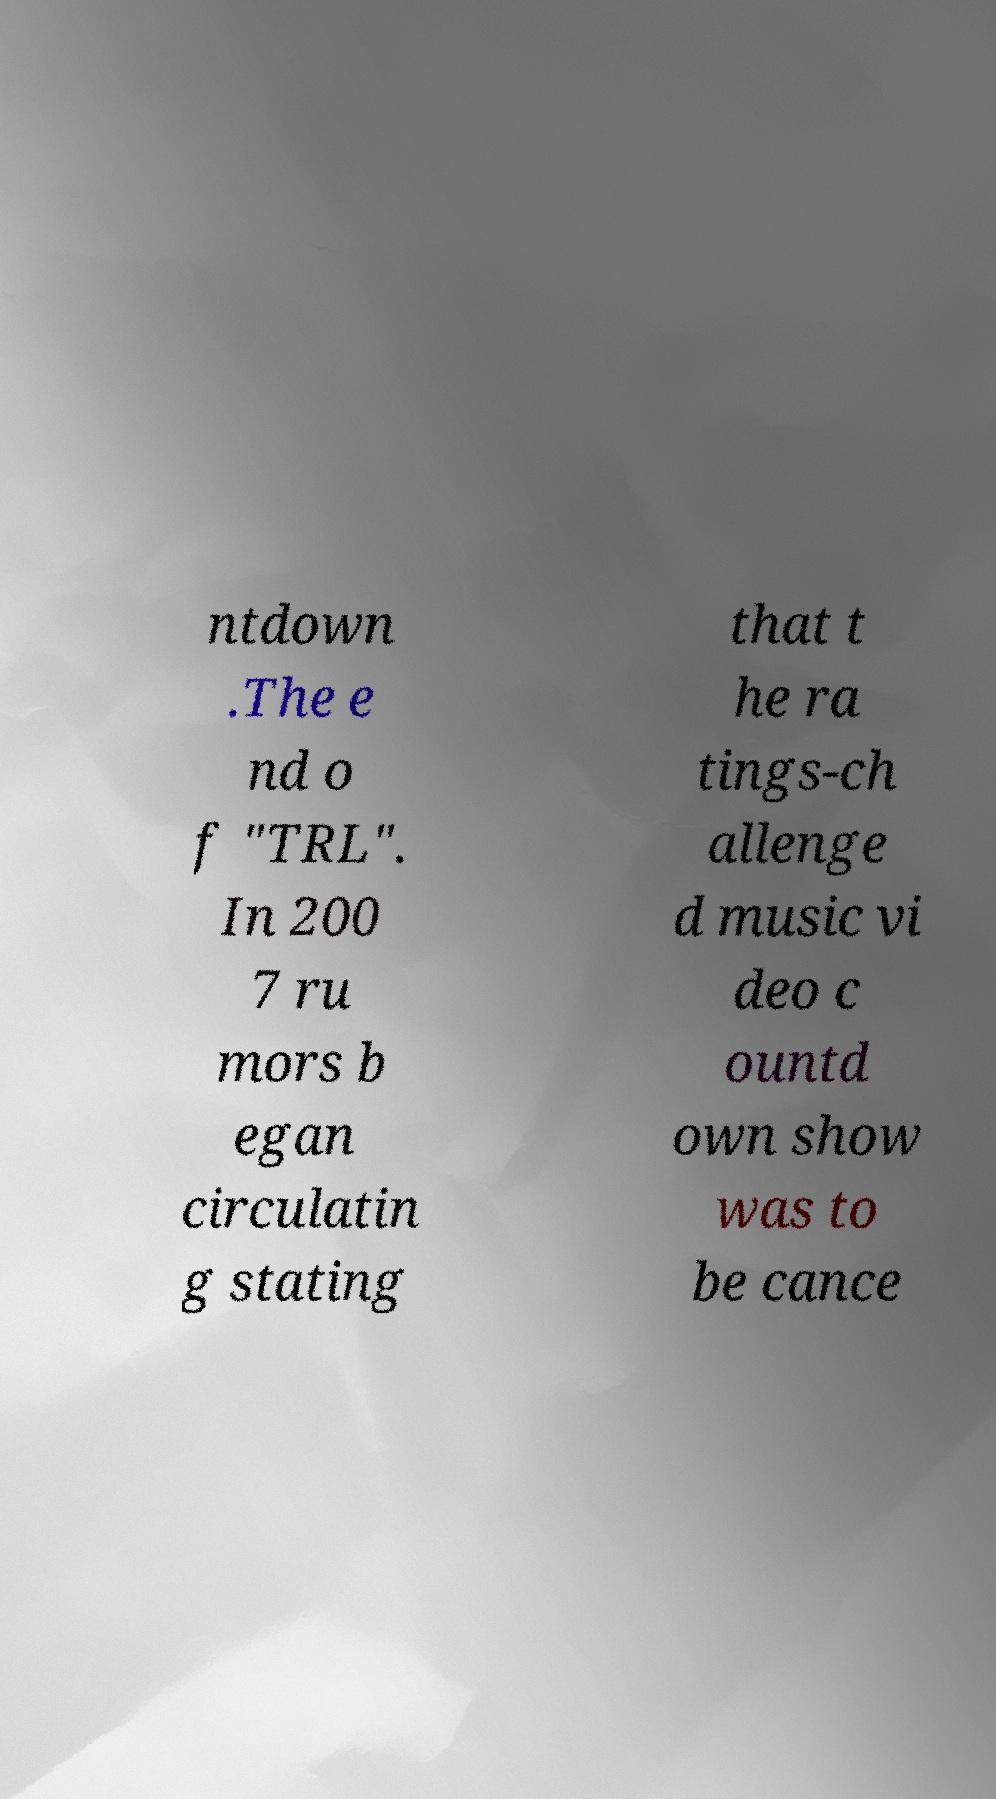Could you extract and type out the text from this image? ntdown .The e nd o f "TRL". In 200 7 ru mors b egan circulatin g stating that t he ra tings-ch allenge d music vi deo c ountd own show was to be cance 